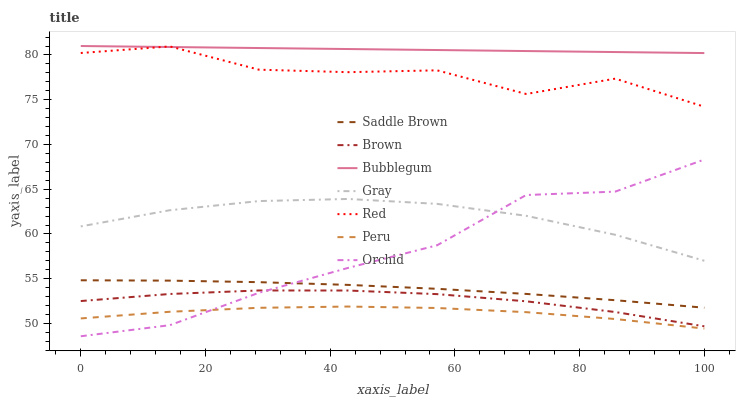Does Peru have the minimum area under the curve?
Answer yes or no. Yes. Does Bubblegum have the maximum area under the curve?
Answer yes or no. Yes. Does Gray have the minimum area under the curve?
Answer yes or no. No. Does Gray have the maximum area under the curve?
Answer yes or no. No. Is Bubblegum the smoothest?
Answer yes or no. Yes. Is Red the roughest?
Answer yes or no. Yes. Is Gray the smoothest?
Answer yes or no. No. Is Gray the roughest?
Answer yes or no. No. Does Gray have the lowest value?
Answer yes or no. No. Does Gray have the highest value?
Answer yes or no. No. Is Gray less than Bubblegum?
Answer yes or no. Yes. Is Red greater than Peru?
Answer yes or no. Yes. Does Gray intersect Bubblegum?
Answer yes or no. No. 